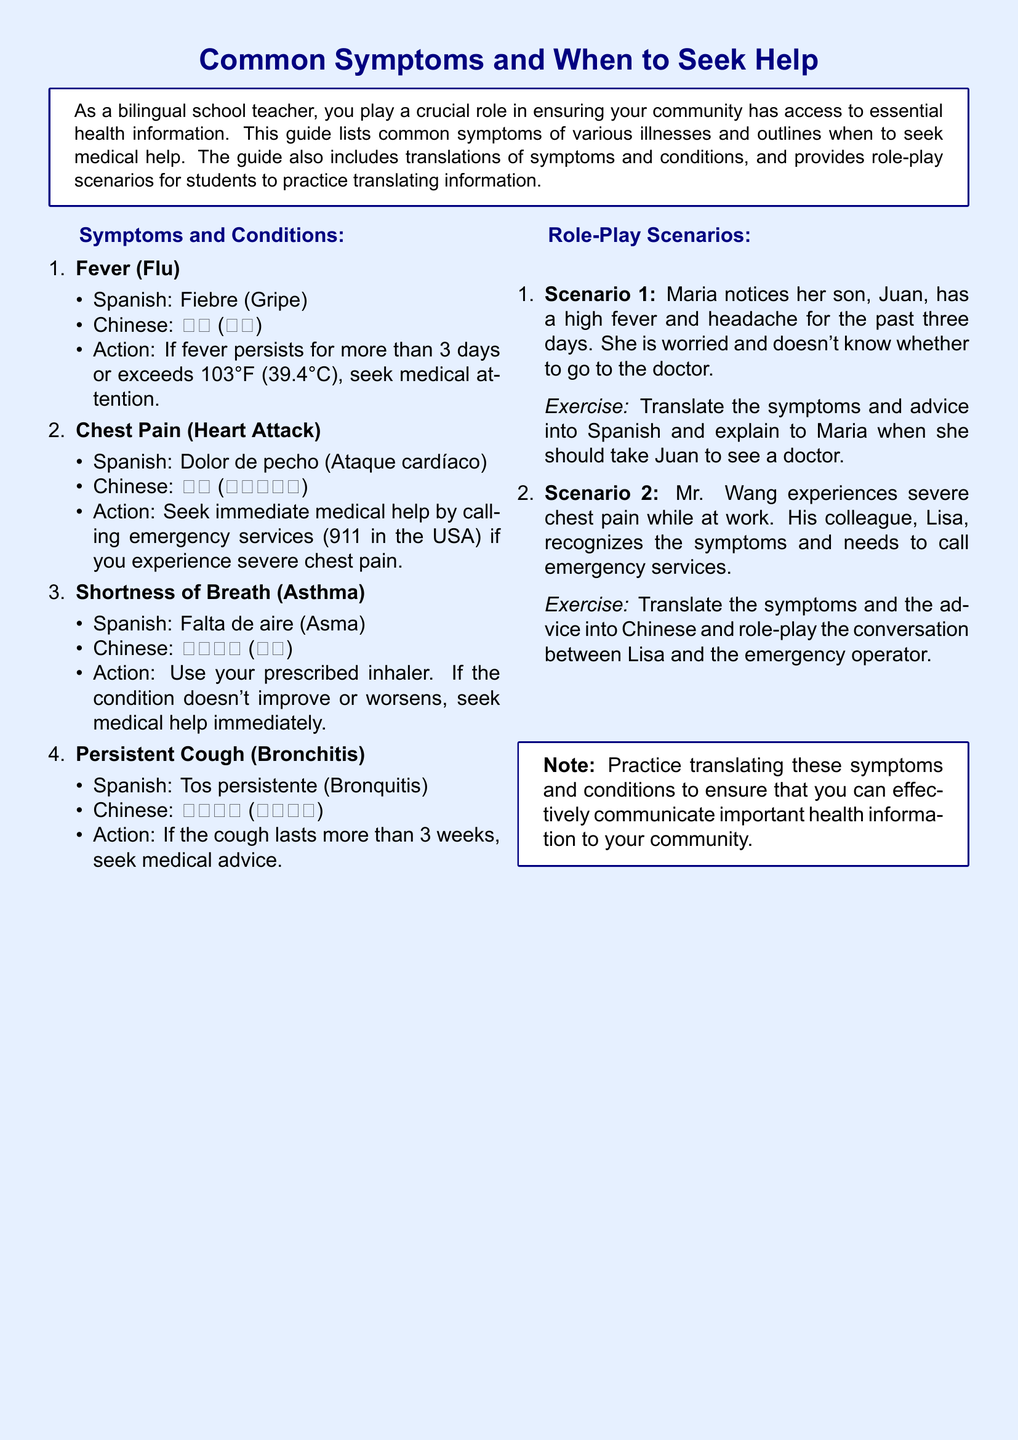What is the translation for "Fever" in Spanish? The document provides translations for symptoms and the Spanish translation for "Fever" is mentioned.
Answer: Fiebre How long should a fever last before seeking medical attention? The document states that if fever persists for more than 3 days or exceeds 103°F, you should seek medical attention.
Answer: More than 3 days What should you do if you experience severe chest pain? The document specifies that you should seek immediate medical help by calling emergency services.
Answer: Call emergency services What are the symptoms that Maria notices in her son? The scenario outlines the symptoms that Maria notices in her son, which are a high fever and headache.
Answer: High fever and headache What action should be taken if a persistent cough lasts more than 3 weeks? The guide advises seeking medical advice if the cough persists for that duration.
Answer: Seek medical advice In Scenario 2, who recognizes the symptoms of Mr. Wang? The scenario notes that his colleague, Lisa, recognizes the symptoms of Mr. Wang.
Answer: Lisa What is the Chinese translation for "Shortness of Breath"? The document includes translations, and the Chinese translation for "Shortness of Breath" is provided.
Answer: 呼吸急促 How many role-play scenarios are provided in the document? The document lists the number of role-play scenarios included, which is two.
Answer: Two 